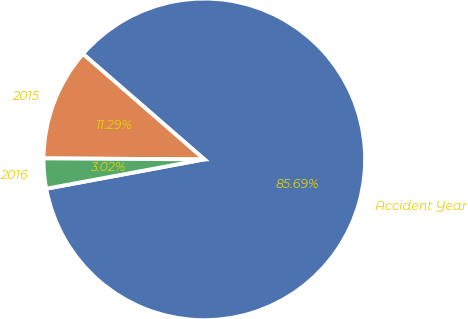Convert chart. <chart><loc_0><loc_0><loc_500><loc_500><pie_chart><fcel>Accident Year<fcel>2015<fcel>2016<nl><fcel>85.7%<fcel>11.29%<fcel>3.02%<nl></chart> 